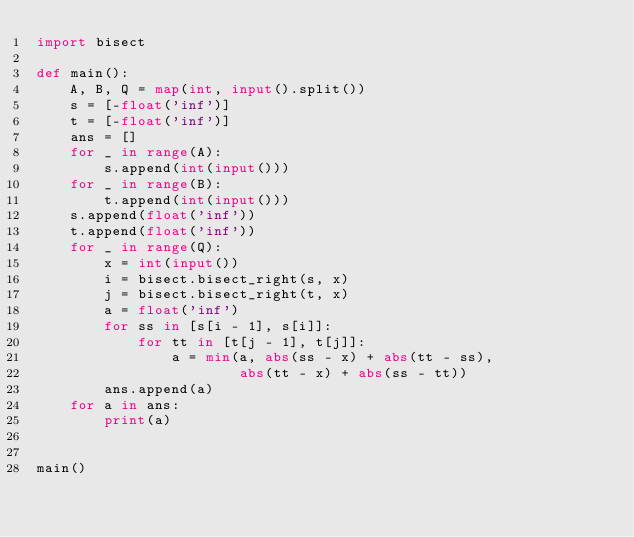<code> <loc_0><loc_0><loc_500><loc_500><_Python_>import bisect

def main():
    A, B, Q = map(int, input().split())
    s = [-float('inf')]
    t = [-float('inf')]
    ans = []
    for _ in range(A):
        s.append(int(input()))
    for _ in range(B):
        t.append(int(input()))
    s.append(float('inf'))
    t.append(float('inf'))
    for _ in range(Q):
        x = int(input())
        i = bisect.bisect_right(s, x)
        j = bisect.bisect_right(t, x)
        a = float('inf')
        for ss in [s[i - 1], s[i]]:
            for tt in [t[j - 1], t[j]]:
                a = min(a, abs(ss - x) + abs(tt - ss),
                        abs(tt - x) + abs(ss - tt))
        ans.append(a)
    for a in ans:
        print(a)


main()
</code> 